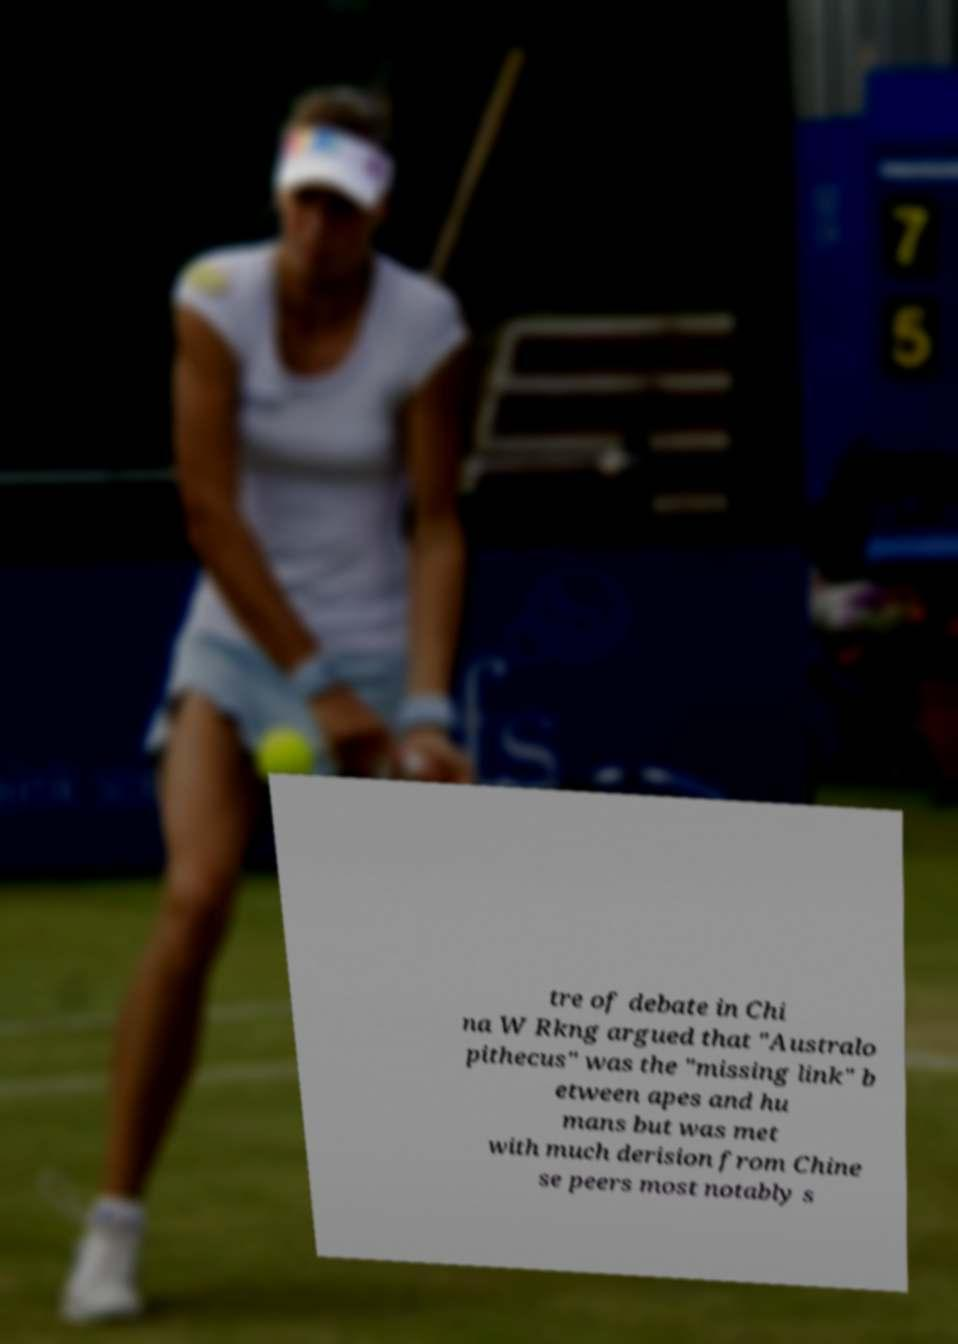Could you assist in decoding the text presented in this image and type it out clearly? tre of debate in Chi na W Rkng argued that "Australo pithecus" was the "missing link" b etween apes and hu mans but was met with much derision from Chine se peers most notably s 